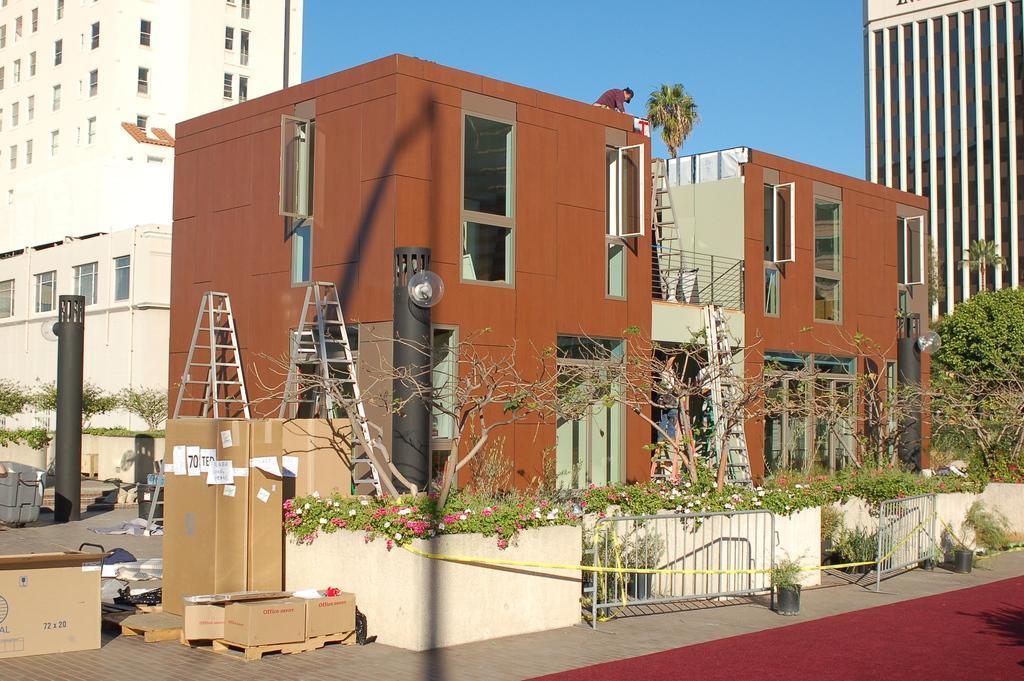Can you describe this image briefly? In this image I see number of buildings and I see few ladders and I see a person over here and I see the path. I can also see the plants on which there are flowers which are of white and pink in color and I see number of boxes over here and I see few trees. In the background I see the blue sky and I see black poles over here. 